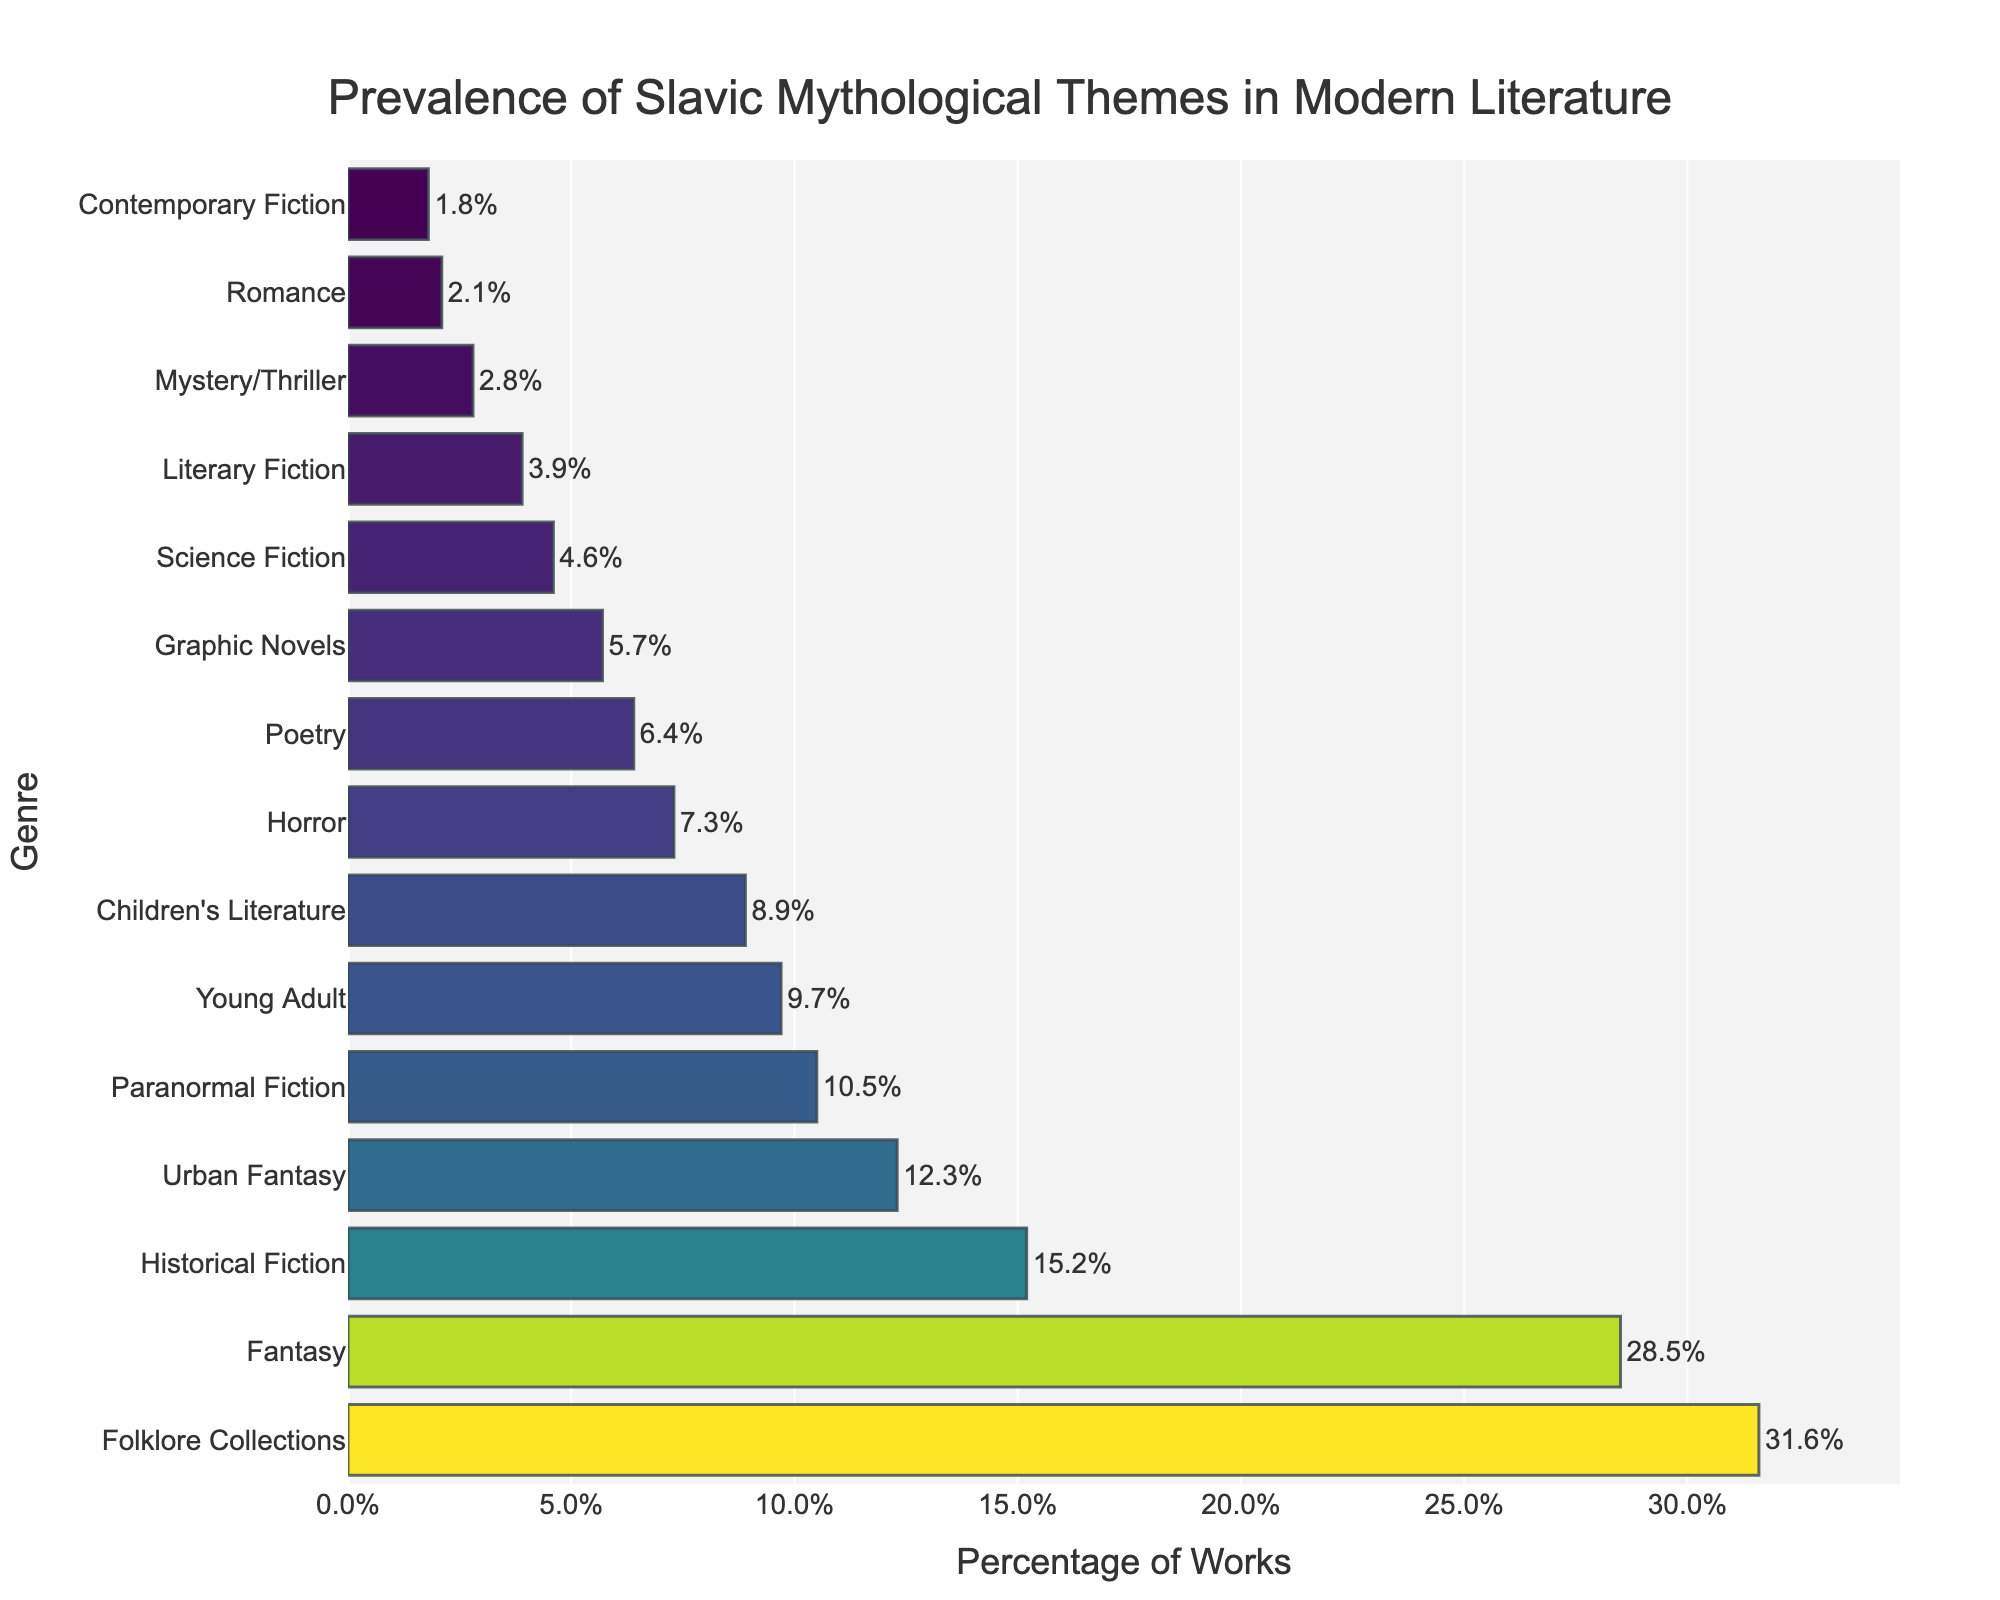Which genre has the highest prevalence of Slavic mythological themes? The genre with the highest bar represents the genre with the most significant percentage. Here, "Folklore Collections" has the tallest bar.
Answer: Folklore Collections Which genre has the lowest prevalence of Slavic mythological themes? The genre with the shortest bar represents the genre with the smallest percentage. Here, "Contemporary Fiction" has the shortest bar.
Answer: Contemporary Fiction What is the total percentage of works with Slavic mythological themes across the top three genres? The top three genres are "Folklore Collections" (31.6%), "Fantasy" (28.5%), and "Historical Fiction" (15.2%). Summing them gives 31.6 + 28.5 + 15.2 = 75.3%.
Answer: 75.3% How much more prevalent are Slavic mythological themes in Fantasy literature compared to Science Fiction literature? The percentages are 28.5% for Fantasy and 4.6% for Science Fiction. The difference is 28.5 - 4.6 = 23.9%.
Answer: 23.9% Which genres have a prevalence of Slavic mythological themes between 5% and 10%? The bars with percentages between 5% and 10% are "Young Adult" (9.7%), "Poetry" (6.4%), "Graphic Novels" (5.7%), "Children's Literature" (8.9%), and "Paranormal Fiction" (10.5%).
Answer: Young Adult, Poetry, Graphic Novels, Children’s Literature, Paranormal Fiction What percentage of works in the Romance genre contain Slavic mythological themes? Look at the bar corresponding to Romance, which shows 2.1%.
Answer: 2.1% Does Urban Fantasy have a higher percentage of works with Slavic mythological themes than Horror? Urban Fantasy has 12.3%, while Horror has 7.3%. Since 12.3 > 7.3, Urban Fantasy has a higher percentage.
Answer: Yes What is the average percentage of works with Slavic mythological themes across all genres? Sum all percentage values and divide by the total number of genres. (318.3/15 ≈ 21.22%).
Answer: 21.22% Which genres have exactly or almost equal prevalence of Slavic mythological themes, looking visually? "Science Fiction" and "Graphic Novels" appear nearly equal in bar length, being 4.6% and 5.7%, respectively.
Answer: Science Fiction, Graphic Novels How does the prevalence of Slavic mythological themes in Mysteries/Thrillers compare to Historical Fiction? Mysteries/Thrillers have 2.8%, while Historical Fiction has 15.2%. Since 2.8 < 15.2, Historical Fiction has a higher prevalence.
Answer: Lower 